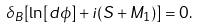Convert formula to latex. <formula><loc_0><loc_0><loc_500><loc_500>\delta _ { B } [ \ln [ d \phi ] + i ( S + M _ { 1 } ) ] = 0 .</formula> 